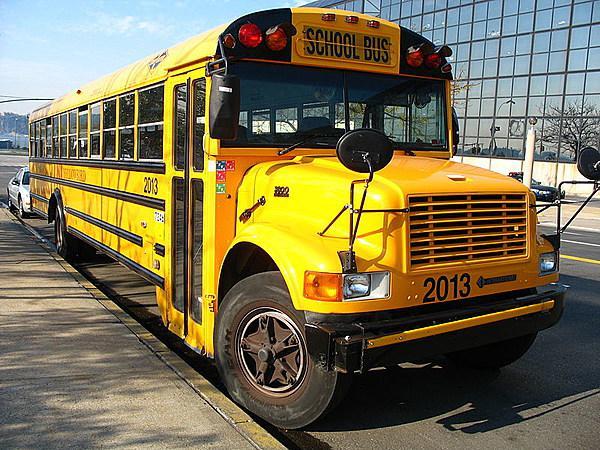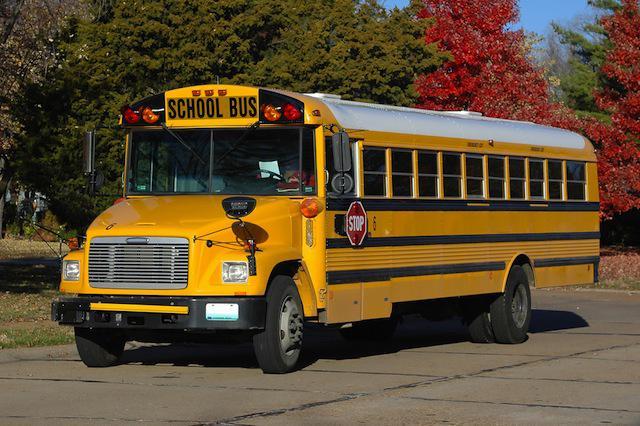The first image is the image on the left, the second image is the image on the right. For the images displayed, is the sentence "The left side of a bus is visible." factually correct? Answer yes or no. Yes. The first image is the image on the left, the second image is the image on the right. Given the left and right images, does the statement "Each image features an angled forward-facing bus, but the buses in the left and right images face opposite directions." hold true? Answer yes or no. Yes. 